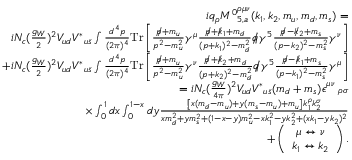<formula> <loc_0><loc_0><loc_500><loc_500>\begin{array} { r l r } & { i q _ { \rho } { M ^ { 0 } } _ { 5 , a } ^ { \rho \mu \nu } ( k _ { 1 } , k _ { 2 } , m _ { u } , m _ { d } , m _ { s } ) = } \\ & { i N _ { c } ( \frac { g _ { W } } { 2 } ) ^ { 2 } V _ { u d } { V ^ { \ast } } _ { u \bar { s } } \int \frac { d ^ { 4 } p } { ( 2 \pi ) ^ { 4 } } { T r } \left [ \frac { p \, / + m _ { u } } { p ^ { 2 } - m _ { u } ^ { 2 } } \gamma ^ { \mu } \frac { p \, / + k \, / _ { 1 } + m _ { d } } { ( p + k _ { 1 } ) ^ { 2 } - m _ { d } ^ { 2 } } q \, / \gamma ^ { 5 } \frac { p \, / - k \, / _ { 2 } + m _ { s } } { ( p - k _ { 2 } ) ^ { 2 } - m _ { s } ^ { 2 } } \gamma ^ { \nu } \right ] } \\ & { + i N _ { c } ( \frac { g _ { W } } { 2 } ) ^ { 2 } V _ { u d } { V ^ { \ast } } _ { u \bar { s } } \int \frac { d ^ { 4 } p } { ( 2 \pi ) ^ { 4 } } { T r } \left [ \frac { p \, / + m _ { u } } { p ^ { 2 } - m _ { u } ^ { 2 } } \gamma ^ { \nu } \frac { p \, / + k \, / _ { 2 } + m _ { d } } { ( p + k _ { 2 } ) ^ { 2 } - m _ { d } ^ { 2 } } q \, / \gamma ^ { 5 } \frac { p \, / - k \, / _ { 1 } + m _ { s } } { ( p - k _ { 1 } ) ^ { 2 } - m _ { s } ^ { 2 } } \gamma ^ { \mu } \right ] } \\ & { = i N _ { c } ( \frac { g _ { W } } { 4 \pi } ) ^ { 2 } V _ { u d } { V ^ { \ast } } _ { u \bar { s } } ( m _ { d } + m _ { s } ) \epsilon _ { \quad \rho \sigma } ^ { \mu \nu } } \\ & { \times \int _ { 0 } ^ { 1 } d x \int _ { 0 } ^ { 1 - x } d y \frac { \left [ x ( m _ { d } - m _ { u } ) + y ( m _ { s } - m _ { u } ) + m _ { u } \right ] k _ { 1 } ^ { \rho } k _ { 2 } ^ { \sigma } } { x m _ { d } ^ { 2 } + y m _ { s } ^ { 2 } + ( 1 - x - y ) m _ { u } ^ { 2 } - x k _ { 1 } ^ { 2 } - y k _ { 2 } ^ { 2 } + ( x k _ { 1 } - y k _ { 2 } ) ^ { 2 } } } \\ & { + \left ( \begin{array} { c } { \mu \leftrightarrow \nu } \\ { k _ { 1 } \leftrightarrow k _ { 2 } } \end{array} \right ) . } \end{array}</formula> 